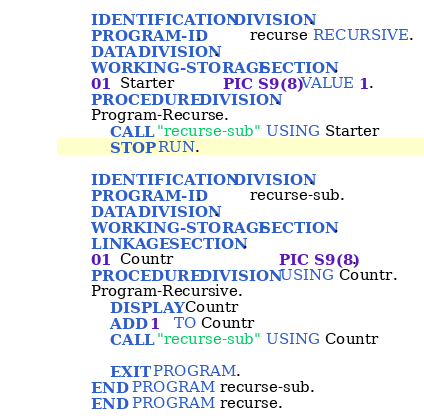<code> <loc_0><loc_0><loc_500><loc_500><_COBOL_>       IDENTIFICATION DIVISION.
       PROGRAM-ID.          recurse RECURSIVE.
       DATA DIVISION.
       WORKING-STORAGE SECTION.
       01  Starter          PIC S9(8) VALUE 1.
       PROCEDURE DIVISION.
       Program-Recurse.
           CALL "recurse-sub" USING Starter
           STOP RUN.

       IDENTIFICATION DIVISION.
       PROGRAM-ID.          recurse-sub.
       DATA DIVISION.
       WORKING-STORAGE SECTION.
       LINKAGE SECTION.
       01  Countr                      PIC S9(8).
       PROCEDURE DIVISION USING Countr.
       Program-Recursive.
           DISPLAY Countr
           ADD 1   TO Countr
           CALL "recurse-sub" USING Countr

           EXIT PROGRAM.
       END PROGRAM recurse-sub.
       END PROGRAM recurse.
</code> 